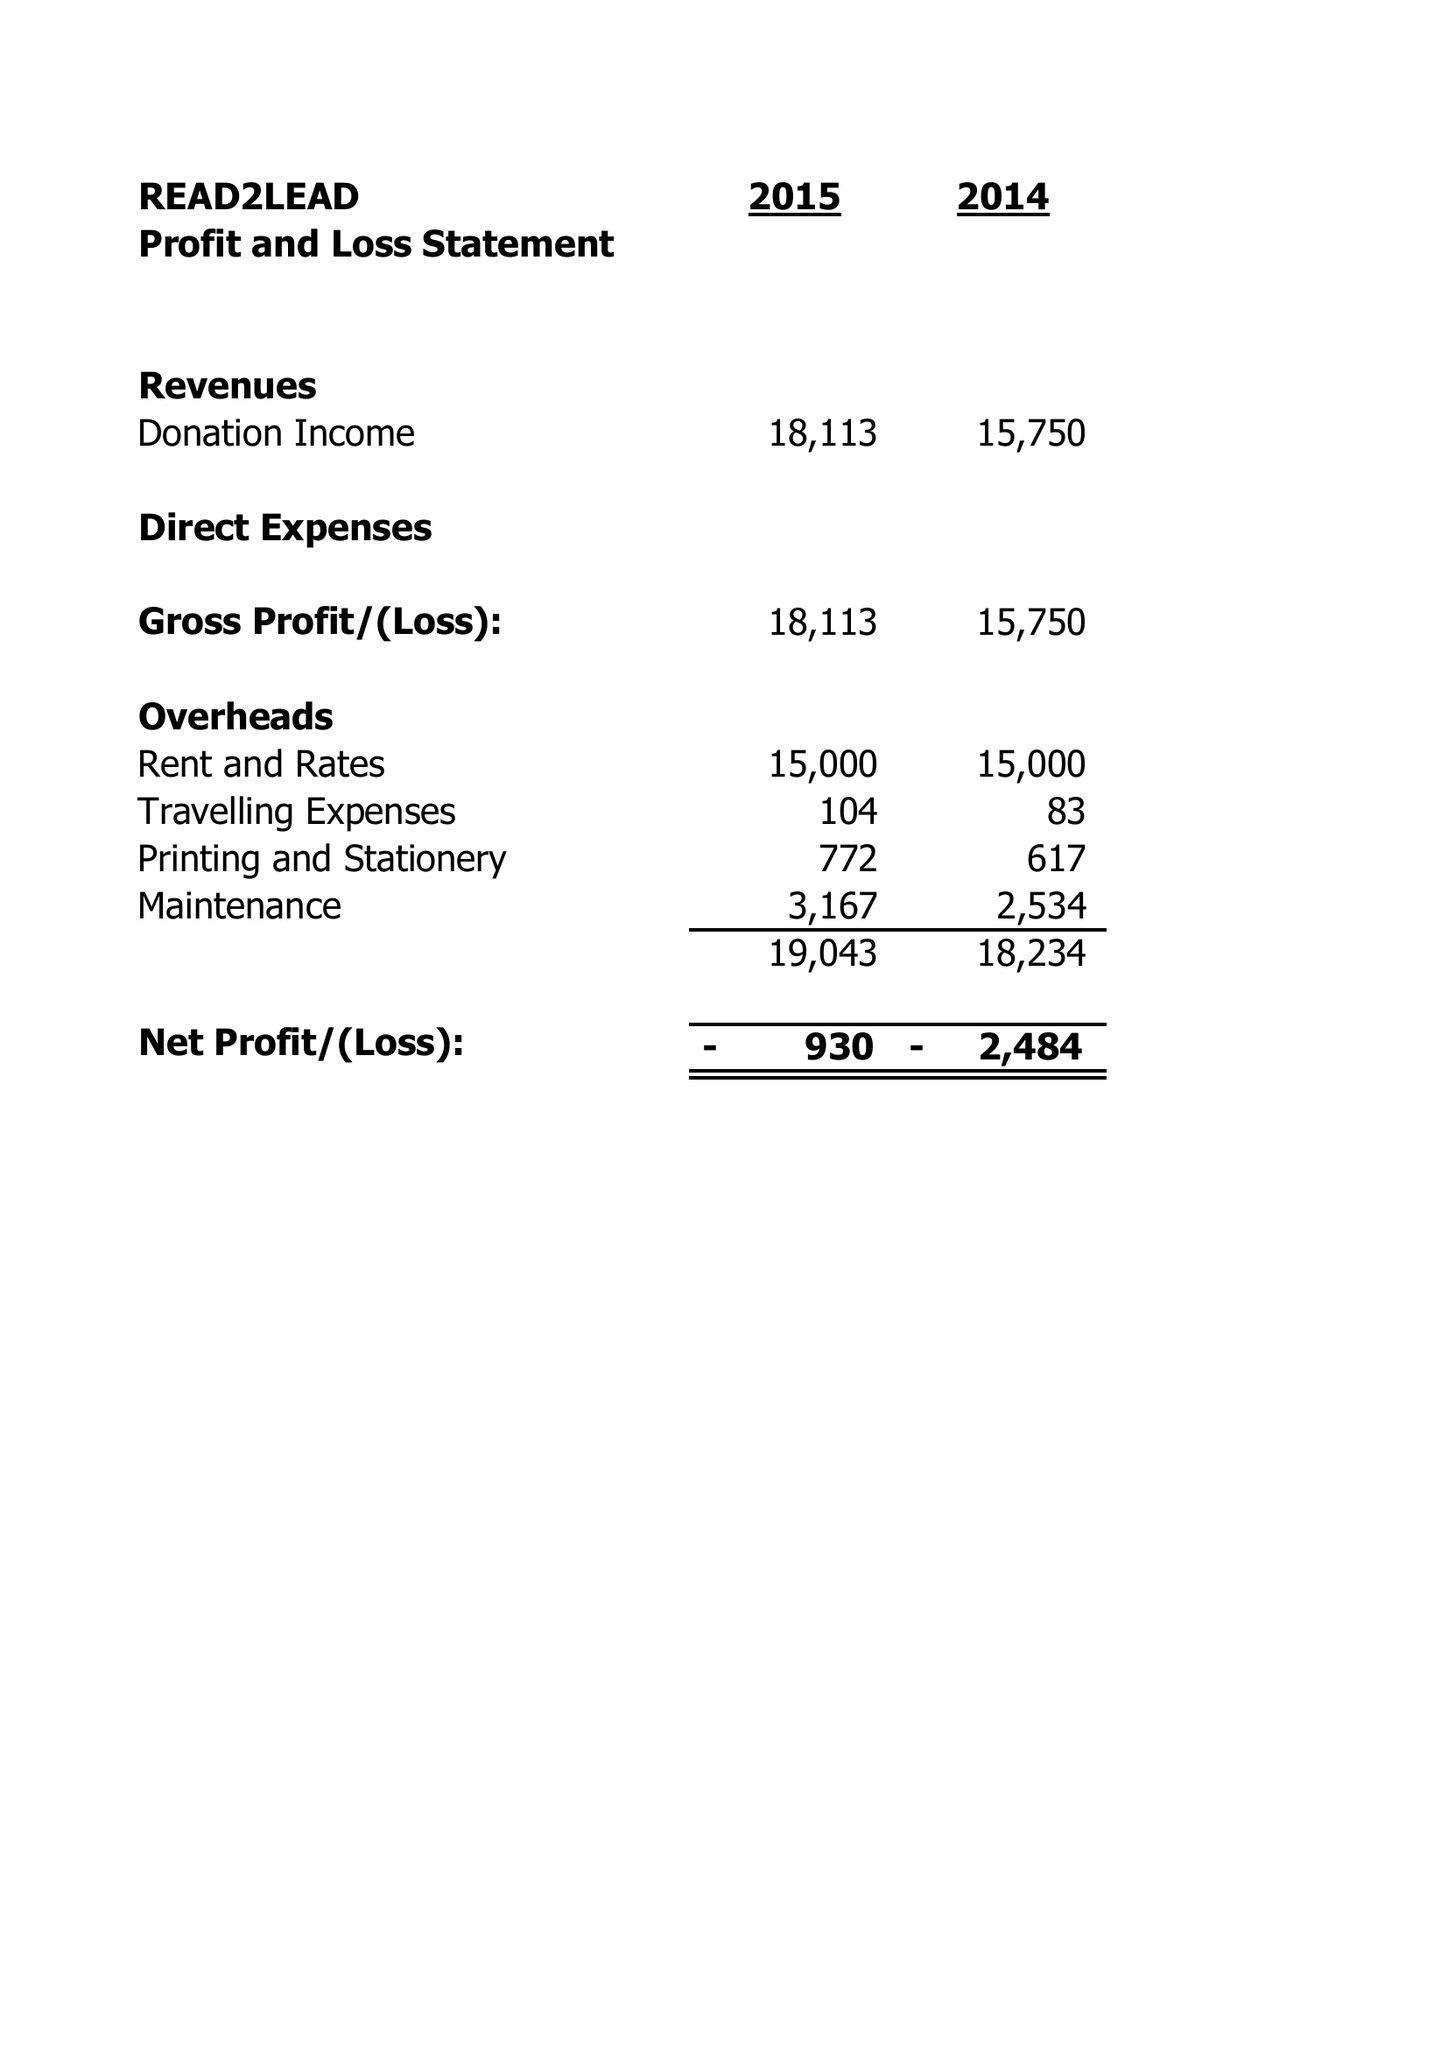What is the value for the address__post_town?
Answer the question using a single word or phrase. BIRMINGHAM 